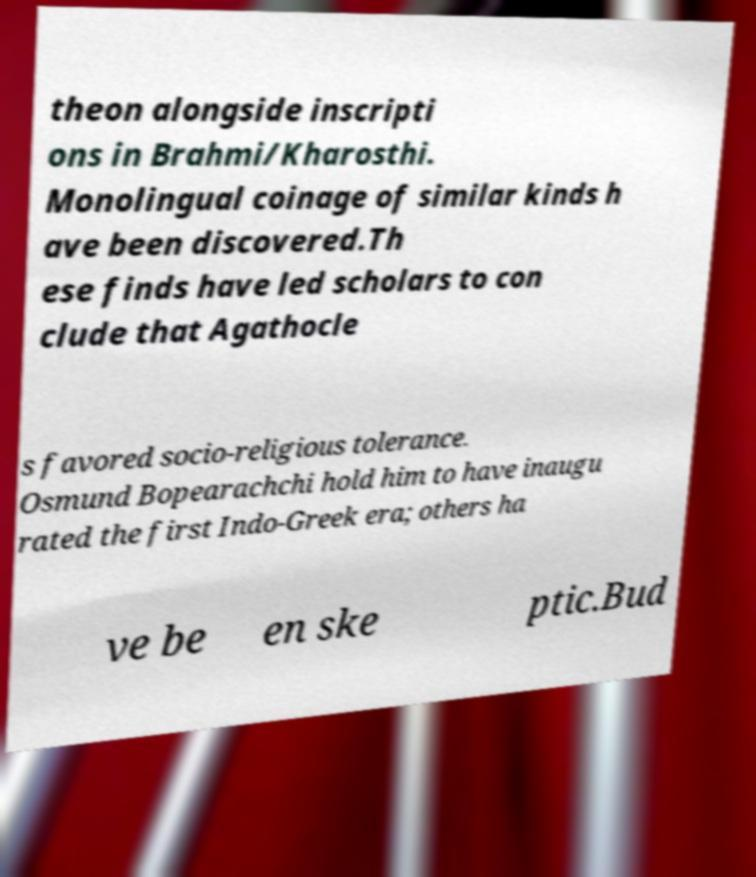Could you assist in decoding the text presented in this image and type it out clearly? theon alongside inscripti ons in Brahmi/Kharosthi. Monolingual coinage of similar kinds h ave been discovered.Th ese finds have led scholars to con clude that Agathocle s favored socio-religious tolerance. Osmund Bopearachchi hold him to have inaugu rated the first Indo-Greek era; others ha ve be en ske ptic.Bud 